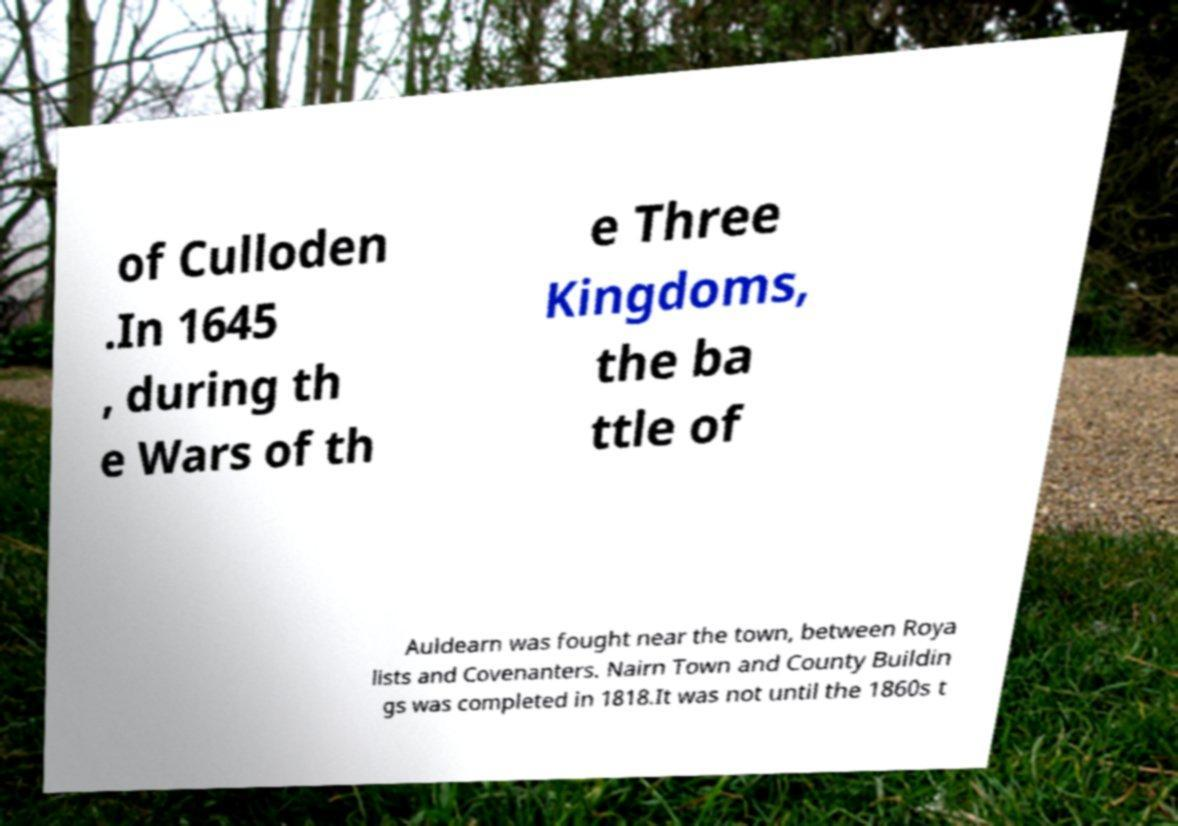Please read and relay the text visible in this image. What does it say? of Culloden .In 1645 , during th e Wars of th e Three Kingdoms, the ba ttle of Auldearn was fought near the town, between Roya lists and Covenanters. Nairn Town and County Buildin gs was completed in 1818.It was not until the 1860s t 